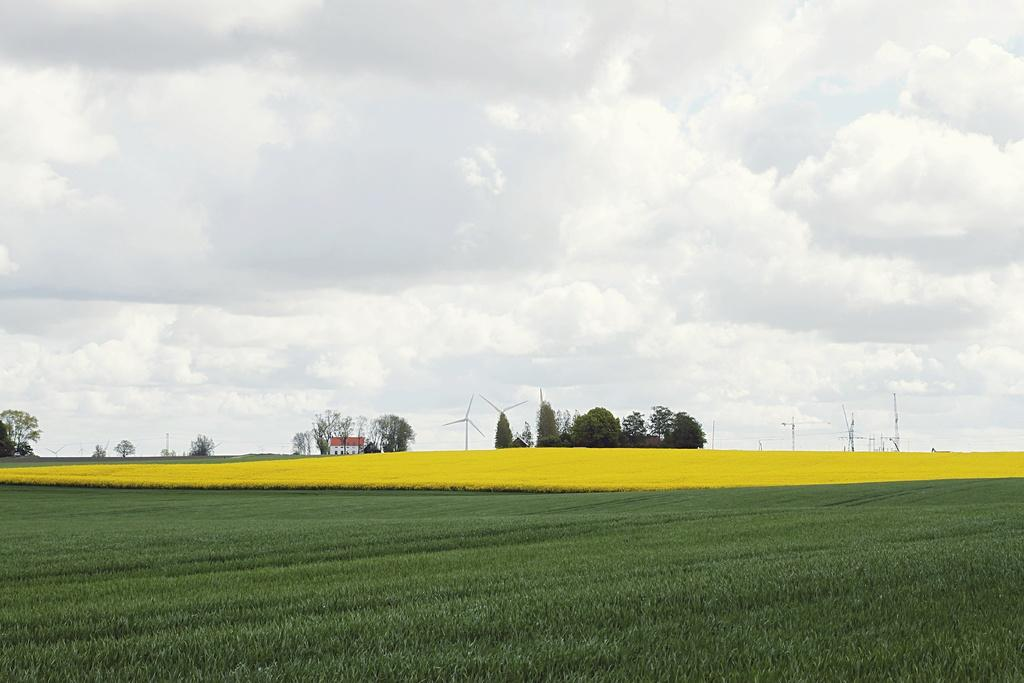What type of landscape is depicted in the image? The image features agricultural farms. What natural elements can be seen in the image? There are trees in the image. Are there any man-made structures visible? Yes, there is at least one building and electric poles present in the image. What type of energy infrastructure is visible? Windmills are visible in the image. What is visible in the sky in the image? The sky is visible in the image, and clouds are present. Where is the lunchroom located in the image? There is no lunchroom present in the image. What color is the lip of the person in the image? There are no people visible in the image, so it is not possible to determine the color of anyone's lip. 